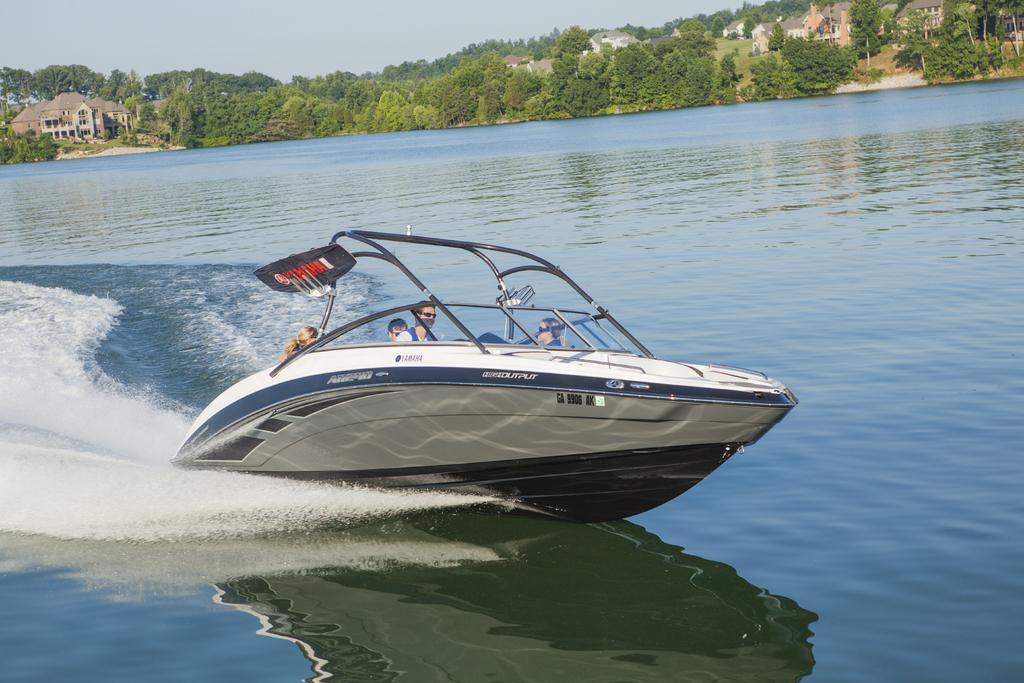In one or two sentences, can you explain what this image depicts? In this picture we can see a few people on the boat. Waves are visible in the water. We can see the reflection of a boat in the water. There are a few trees and houses visible in the background. 